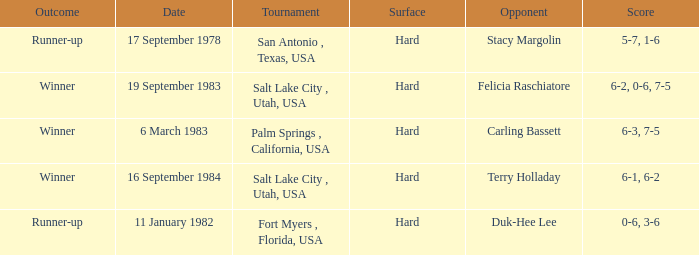What was the outcome of the match against Stacy Margolin? Runner-up. 